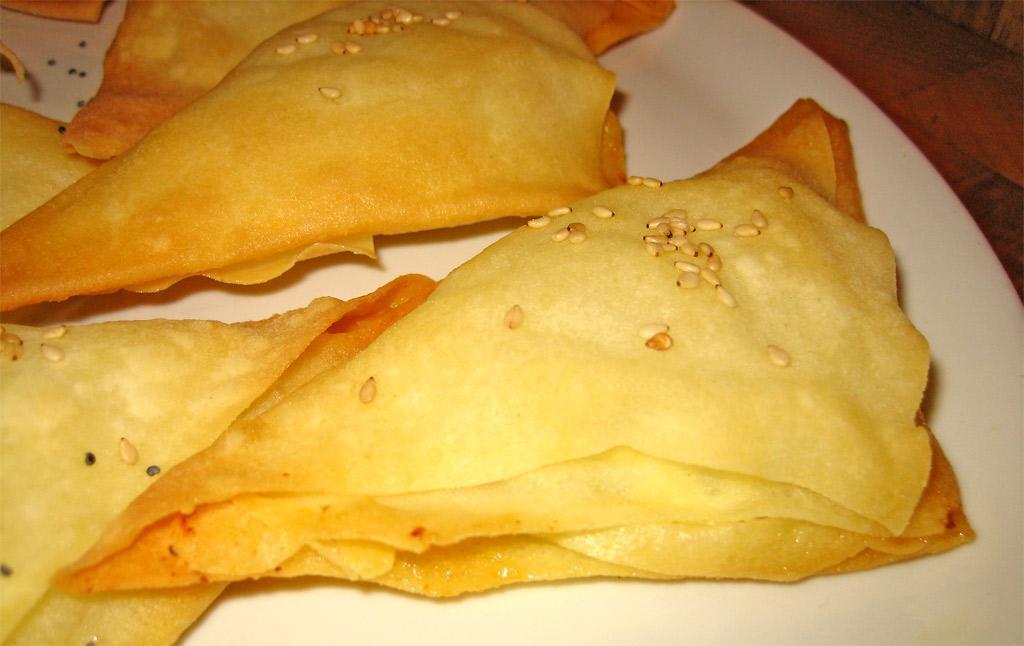In one or two sentences, can you explain what this image depicts? In this picture, we can see some food on the plate which is kept on the surface. 